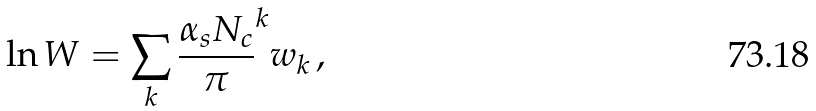<formula> <loc_0><loc_0><loc_500><loc_500>\ln W = \sum _ { k } { \frac { \alpha _ { s } N _ { c } } { \pi } } ^ { k } w _ { k } \, ,</formula> 